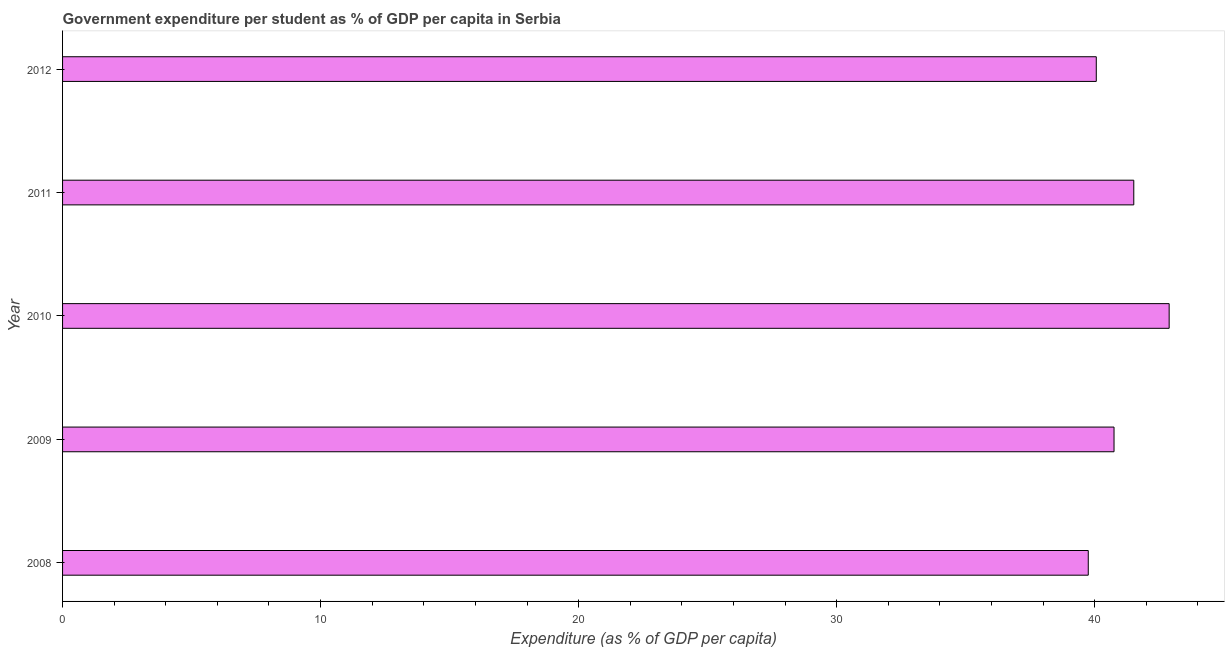Does the graph contain grids?
Your answer should be compact. No. What is the title of the graph?
Ensure brevity in your answer.  Government expenditure per student as % of GDP per capita in Serbia. What is the label or title of the X-axis?
Your response must be concise. Expenditure (as % of GDP per capita). What is the government expenditure per student in 2009?
Your answer should be very brief. 40.75. Across all years, what is the maximum government expenditure per student?
Make the answer very short. 42.89. Across all years, what is the minimum government expenditure per student?
Offer a very short reply. 39.75. What is the sum of the government expenditure per student?
Give a very brief answer. 204.97. What is the difference between the government expenditure per student in 2009 and 2011?
Make the answer very short. -0.77. What is the average government expenditure per student per year?
Provide a succinct answer. 40.99. What is the median government expenditure per student?
Give a very brief answer. 40.75. Do a majority of the years between 2009 and 2010 (inclusive) have government expenditure per student greater than 32 %?
Make the answer very short. Yes. What is the ratio of the government expenditure per student in 2008 to that in 2011?
Provide a succinct answer. 0.96. Is the government expenditure per student in 2009 less than that in 2010?
Provide a succinct answer. Yes. What is the difference between the highest and the second highest government expenditure per student?
Give a very brief answer. 1.37. Is the sum of the government expenditure per student in 2010 and 2011 greater than the maximum government expenditure per student across all years?
Your response must be concise. Yes. What is the difference between the highest and the lowest government expenditure per student?
Offer a terse response. 3.14. Are all the bars in the graph horizontal?
Keep it short and to the point. Yes. Are the values on the major ticks of X-axis written in scientific E-notation?
Your response must be concise. No. What is the Expenditure (as % of GDP per capita) in 2008?
Ensure brevity in your answer.  39.75. What is the Expenditure (as % of GDP per capita) of 2009?
Ensure brevity in your answer.  40.75. What is the Expenditure (as % of GDP per capita) of 2010?
Your answer should be compact. 42.89. What is the Expenditure (as % of GDP per capita) in 2011?
Make the answer very short. 41.52. What is the Expenditure (as % of GDP per capita) of 2012?
Provide a succinct answer. 40.06. What is the difference between the Expenditure (as % of GDP per capita) in 2008 and 2009?
Your response must be concise. -1. What is the difference between the Expenditure (as % of GDP per capita) in 2008 and 2010?
Give a very brief answer. -3.14. What is the difference between the Expenditure (as % of GDP per capita) in 2008 and 2011?
Your response must be concise. -1.76. What is the difference between the Expenditure (as % of GDP per capita) in 2008 and 2012?
Your answer should be very brief. -0.31. What is the difference between the Expenditure (as % of GDP per capita) in 2009 and 2010?
Make the answer very short. -2.14. What is the difference between the Expenditure (as % of GDP per capita) in 2009 and 2011?
Keep it short and to the point. -0.77. What is the difference between the Expenditure (as % of GDP per capita) in 2009 and 2012?
Your answer should be very brief. 0.69. What is the difference between the Expenditure (as % of GDP per capita) in 2010 and 2011?
Offer a terse response. 1.37. What is the difference between the Expenditure (as % of GDP per capita) in 2010 and 2012?
Your answer should be compact. 2.82. What is the difference between the Expenditure (as % of GDP per capita) in 2011 and 2012?
Ensure brevity in your answer.  1.45. What is the ratio of the Expenditure (as % of GDP per capita) in 2008 to that in 2010?
Provide a short and direct response. 0.93. What is the ratio of the Expenditure (as % of GDP per capita) in 2008 to that in 2011?
Your answer should be compact. 0.96. What is the ratio of the Expenditure (as % of GDP per capita) in 2009 to that in 2010?
Make the answer very short. 0.95. What is the ratio of the Expenditure (as % of GDP per capita) in 2009 to that in 2011?
Offer a very short reply. 0.98. What is the ratio of the Expenditure (as % of GDP per capita) in 2009 to that in 2012?
Ensure brevity in your answer.  1.02. What is the ratio of the Expenditure (as % of GDP per capita) in 2010 to that in 2011?
Give a very brief answer. 1.03. What is the ratio of the Expenditure (as % of GDP per capita) in 2010 to that in 2012?
Keep it short and to the point. 1.07. What is the ratio of the Expenditure (as % of GDP per capita) in 2011 to that in 2012?
Keep it short and to the point. 1.04. 